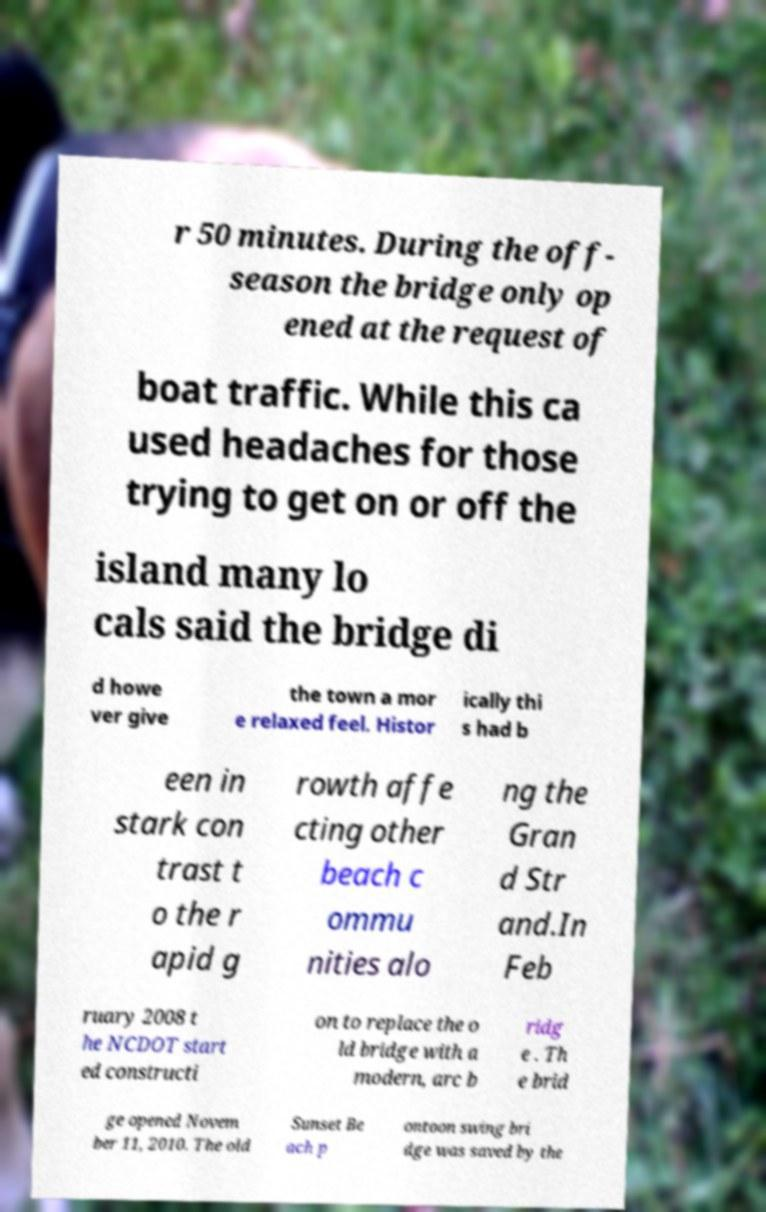There's text embedded in this image that I need extracted. Can you transcribe it verbatim? r 50 minutes. During the off- season the bridge only op ened at the request of boat traffic. While this ca used headaches for those trying to get on or off the island many lo cals said the bridge di d howe ver give the town a mor e relaxed feel. Histor ically thi s had b een in stark con trast t o the r apid g rowth affe cting other beach c ommu nities alo ng the Gran d Str and.In Feb ruary 2008 t he NCDOT start ed constructi on to replace the o ld bridge with a modern, arc b ridg e . Th e brid ge opened Novem ber 11, 2010. The old Sunset Be ach p ontoon swing bri dge was saved by the 